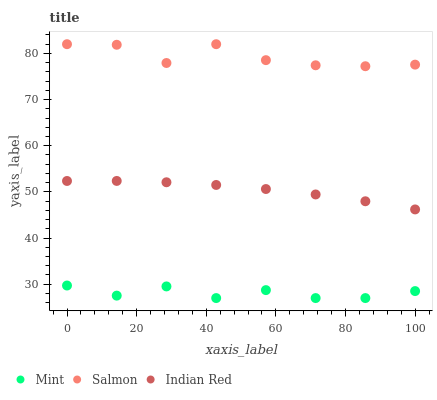Does Mint have the minimum area under the curve?
Answer yes or no. Yes. Does Salmon have the maximum area under the curve?
Answer yes or no. Yes. Does Indian Red have the minimum area under the curve?
Answer yes or no. No. Does Indian Red have the maximum area under the curve?
Answer yes or no. No. Is Indian Red the smoothest?
Answer yes or no. Yes. Is Salmon the roughest?
Answer yes or no. Yes. Is Mint the smoothest?
Answer yes or no. No. Is Mint the roughest?
Answer yes or no. No. Does Mint have the lowest value?
Answer yes or no. Yes. Does Indian Red have the lowest value?
Answer yes or no. No. Does Salmon have the highest value?
Answer yes or no. Yes. Does Indian Red have the highest value?
Answer yes or no. No. Is Mint less than Indian Red?
Answer yes or no. Yes. Is Salmon greater than Indian Red?
Answer yes or no. Yes. Does Mint intersect Indian Red?
Answer yes or no. No. 